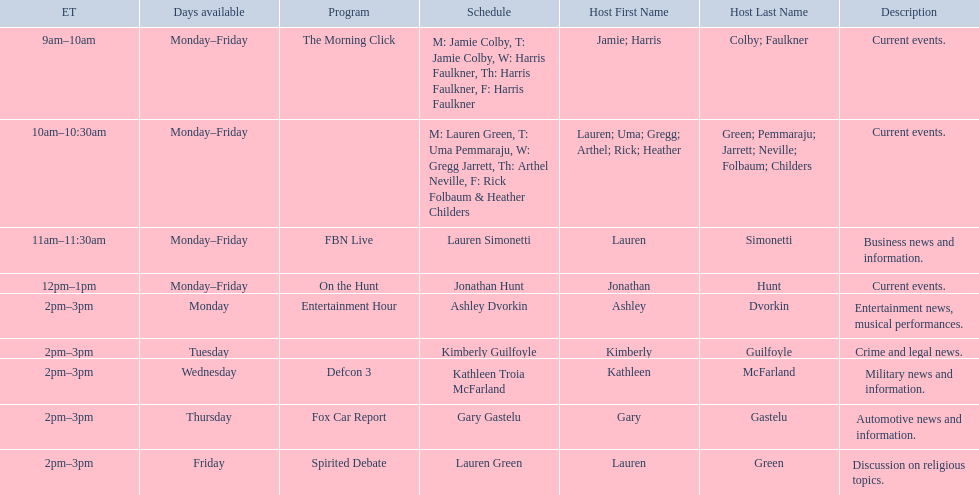How many days during the week does the show fbn live air? 5. 